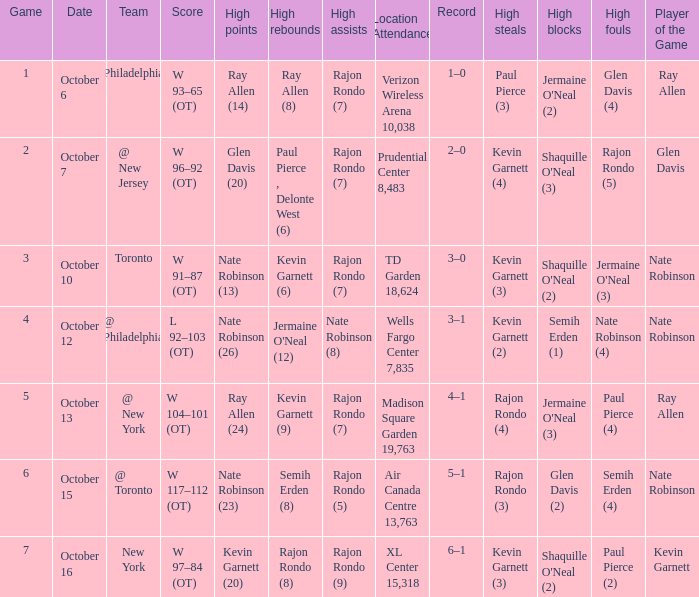Who had the most rebounds and how many did they have on October 16? Rajon Rondo (8). 